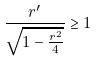Convert formula to latex. <formula><loc_0><loc_0><loc_500><loc_500>\frac { r ^ { \prime } } { \sqrt { 1 - \frac { r ^ { 2 } } { 4 } } } \geq 1</formula> 